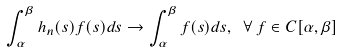Convert formula to latex. <formula><loc_0><loc_0><loc_500><loc_500>\int _ { \alpha } ^ { \beta } h _ { n } ( s ) f ( s ) d s \to \int _ { \alpha } ^ { \beta } f ( s ) d s , \ \forall \, f \in C [ \alpha , \beta ]</formula> 